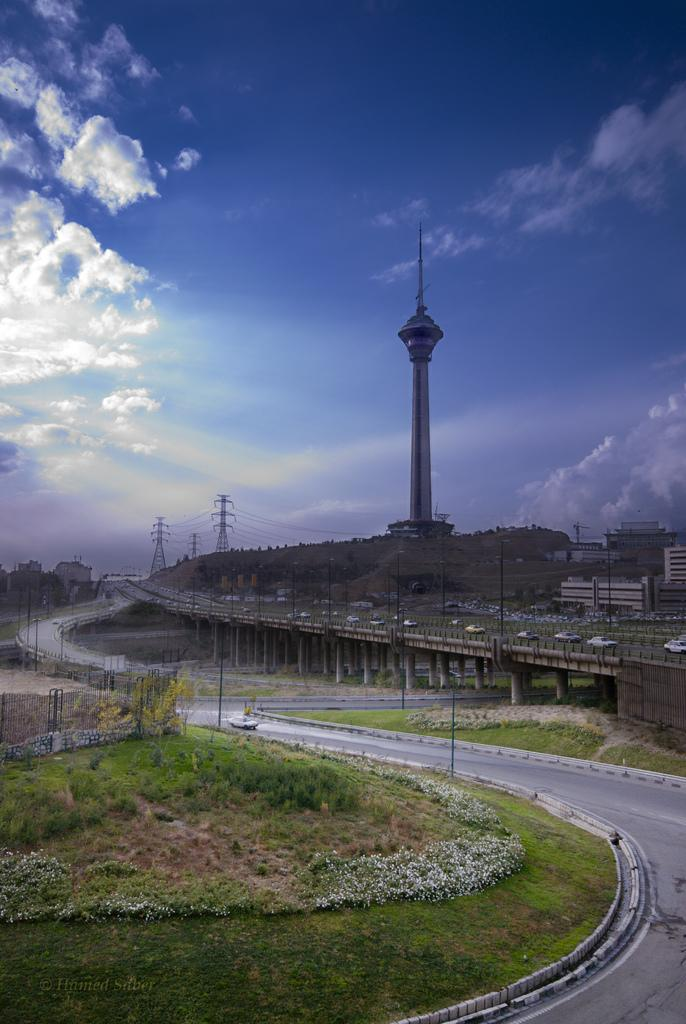What type of vegetation is present in the image? There are trees in the image. What is the color of the trees? The trees are green. What can be seen in the background of the image? There is a building, electric poles, and the sky visible in the background of the image. What is the color of the sky in the image? The sky is blue and white in color. Can you see any goldfish swimming in the trees in the image? No, there are no goldfish present in the image. What type of polish is being used on the electric poles in the image? There is no mention of polish being used on the electric poles in the image. 